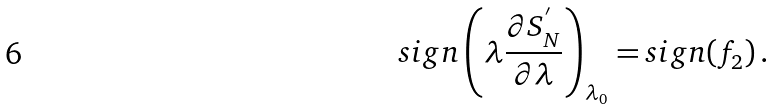Convert formula to latex. <formula><loc_0><loc_0><loc_500><loc_500>s i g n \left ( \lambda { \frac { \partial S _ { N } ^ { ^ { \prime } } } { \partial \lambda } } \right ) _ { \lambda _ { 0 } } = s i g n ( f _ { 2 } ) \, .</formula> 